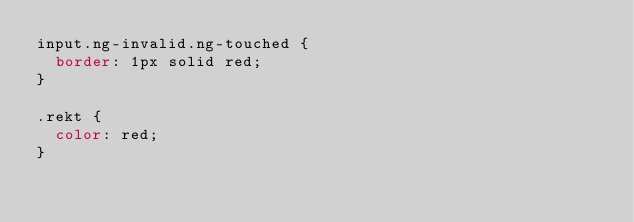<code> <loc_0><loc_0><loc_500><loc_500><_CSS_>input.ng-invalid.ng-touched {
  border: 1px solid red;
}

.rekt {
  color: red;
}
</code> 